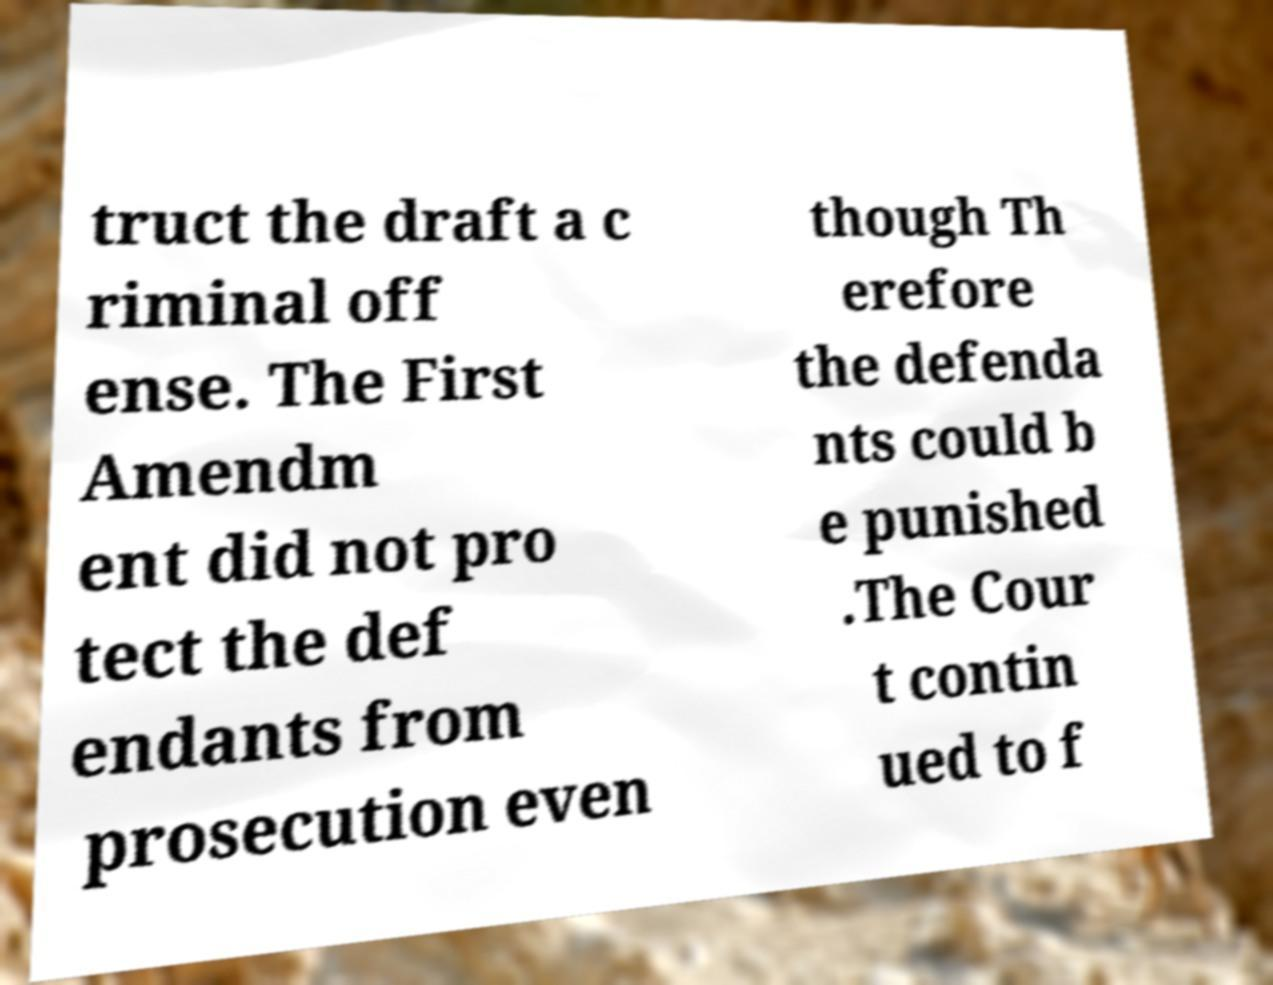Please read and relay the text visible in this image. What does it say? truct the draft a c riminal off ense. The First Amendm ent did not pro tect the def endants from prosecution even though Th erefore the defenda nts could b e punished .The Cour t contin ued to f 